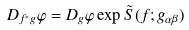Convert formula to latex. <formula><loc_0><loc_0><loc_500><loc_500>D _ { f ^ { \ast } g } \varphi = D _ { g } \varphi \exp { \tilde { S } ( f ; g _ { \alpha \beta } ) }</formula> 